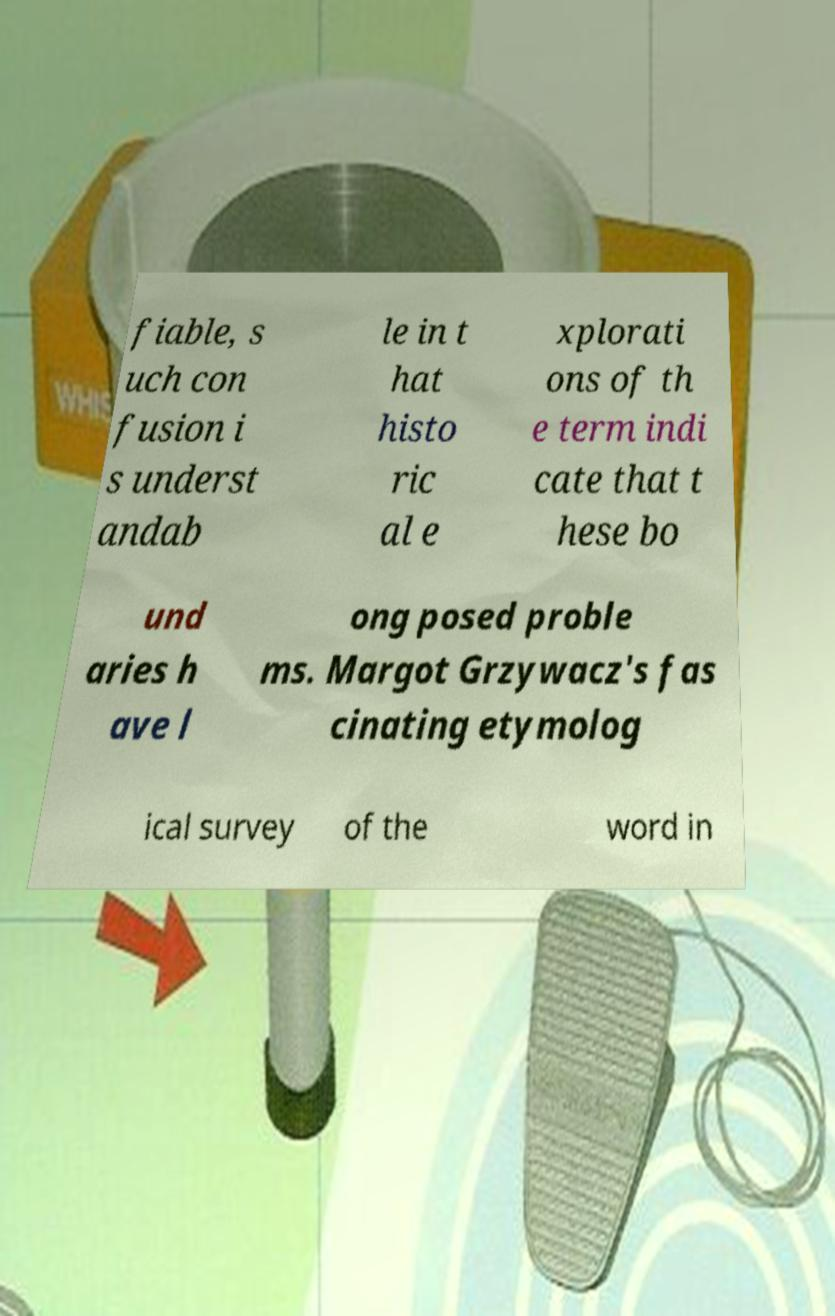Can you accurately transcribe the text from the provided image for me? fiable, s uch con fusion i s underst andab le in t hat histo ric al e xplorati ons of th e term indi cate that t hese bo und aries h ave l ong posed proble ms. Margot Grzywacz's fas cinating etymolog ical survey of the word in 